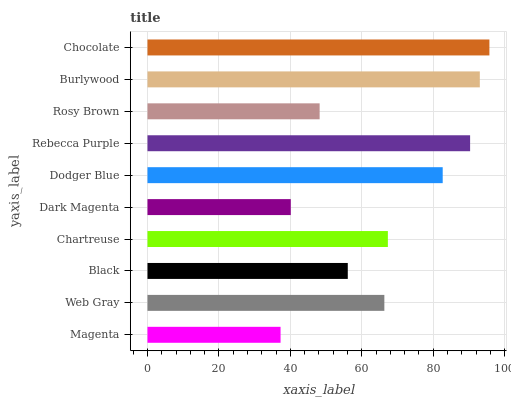Is Magenta the minimum?
Answer yes or no. Yes. Is Chocolate the maximum?
Answer yes or no. Yes. Is Web Gray the minimum?
Answer yes or no. No. Is Web Gray the maximum?
Answer yes or no. No. Is Web Gray greater than Magenta?
Answer yes or no. Yes. Is Magenta less than Web Gray?
Answer yes or no. Yes. Is Magenta greater than Web Gray?
Answer yes or no. No. Is Web Gray less than Magenta?
Answer yes or no. No. Is Chartreuse the high median?
Answer yes or no. Yes. Is Web Gray the low median?
Answer yes or no. Yes. Is Rosy Brown the high median?
Answer yes or no. No. Is Dark Magenta the low median?
Answer yes or no. No. 